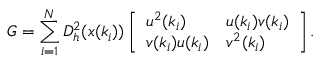<formula> <loc_0><loc_0><loc_500><loc_500>G = \sum _ { i = 1 } ^ { N } D _ { h } ^ { 2 } ( x ( k _ { i } ) ) \left [ \begin{array} { l l } { u ^ { 2 } ( k _ { i } ) } & { u ( k _ { i } ) v ( k _ { i } ) } \\ { v ( k _ { i } ) u ( k _ { i } ) } & { v ^ { 2 } ( k _ { i } ) } \end{array} \right ] .</formula> 